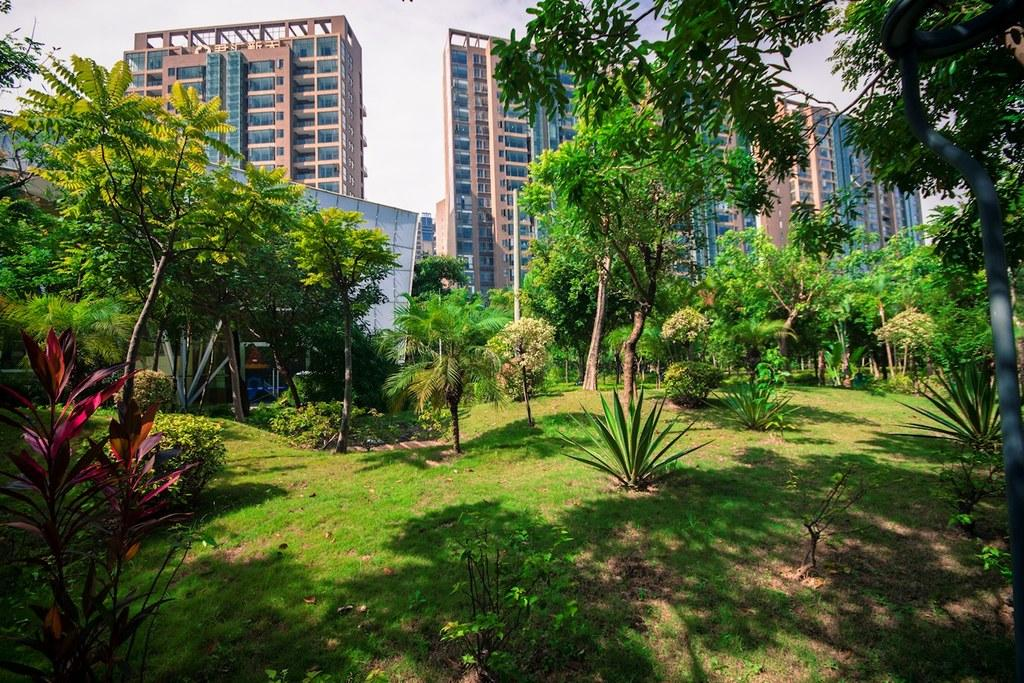What type of environment is depicted in the foreground of the image? The foreground of the picture appears to be a park. What types of vegetation can be seen in the foreground? There are plants and trees in the foreground. What type of ground cover is present in the foreground? There is grass in the foreground. What structures can be seen in the middle of the picture? There are buildings in the middle of the picture. What is visible in the background of the image? The sky is visible in the background of the picture. What advice is being given to the plants in the image? There is no indication in the image that any advice is being given to the plants, as plants do not have the ability to understand or follow advice. 